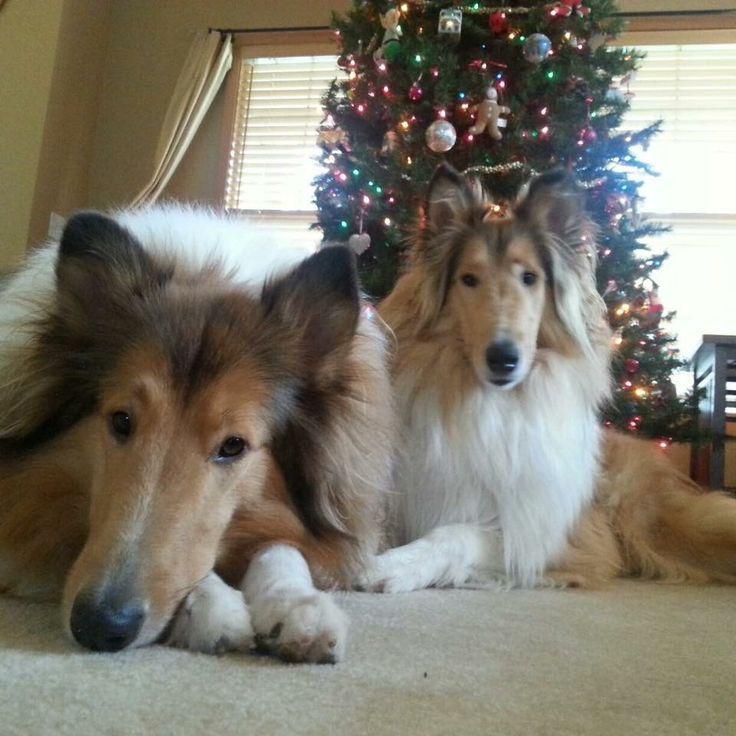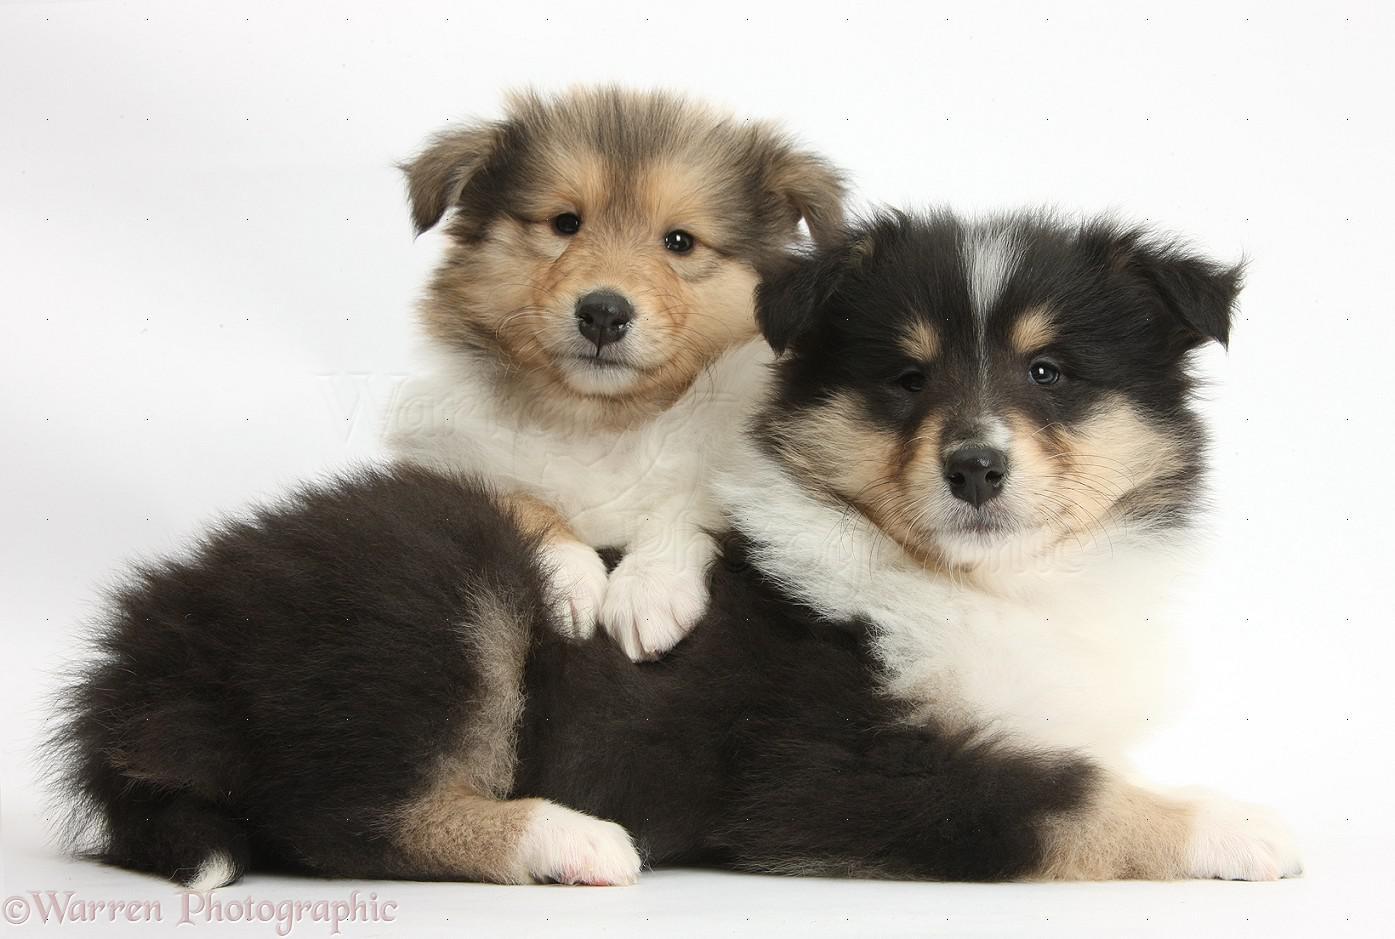The first image is the image on the left, the second image is the image on the right. Analyze the images presented: Is the assertion "There are four adult collies sitting next to each other." valid? Answer yes or no. No. The first image is the image on the left, the second image is the image on the right. Evaluate the accuracy of this statement regarding the images: "An image shows exactly two collie dogs posed outdoors, with one reclining at the left of a dog sitting upright.". Is it true? Answer yes or no. No. 